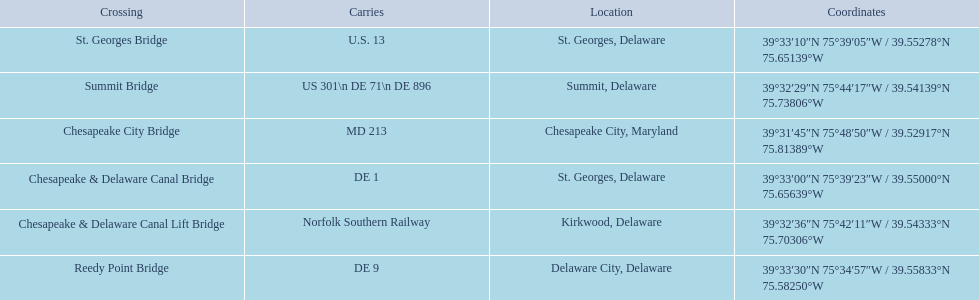What gets carried within the canal? MD 213, US 301\n DE 71\n DE 896, Norfolk Southern Railway, DE 1, U.S. 13, DE 9. Which of those carries de 9? DE 9. To what crossing does that entry correspond? Reedy Point Bridge. 